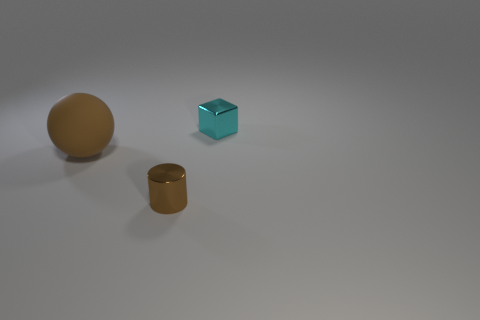Is there any other thing that has the same shape as the rubber thing?
Offer a terse response. No. What number of objects are small brown metal cylinders or brown matte things?
Offer a terse response. 2. The object that is behind the cylinder and right of the large brown object has what shape?
Offer a terse response. Cube. How many big blue metal cubes are there?
Ensure brevity in your answer.  0. There is a tiny cube that is made of the same material as the cylinder; what is its color?
Make the answer very short. Cyan. Is the number of small cyan things greater than the number of small cyan balls?
Your answer should be very brief. Yes. There is a object that is both on the right side of the big brown matte object and behind the tiny cylinder; how big is it?
Your answer should be compact. Small. There is a ball that is the same color as the small cylinder; what is its material?
Your response must be concise. Rubber. Are there the same number of tiny cylinders that are left of the big thing and tiny metallic cubes?
Your answer should be compact. No. Does the cyan metal cube have the same size as the metal cylinder?
Keep it short and to the point. Yes. 